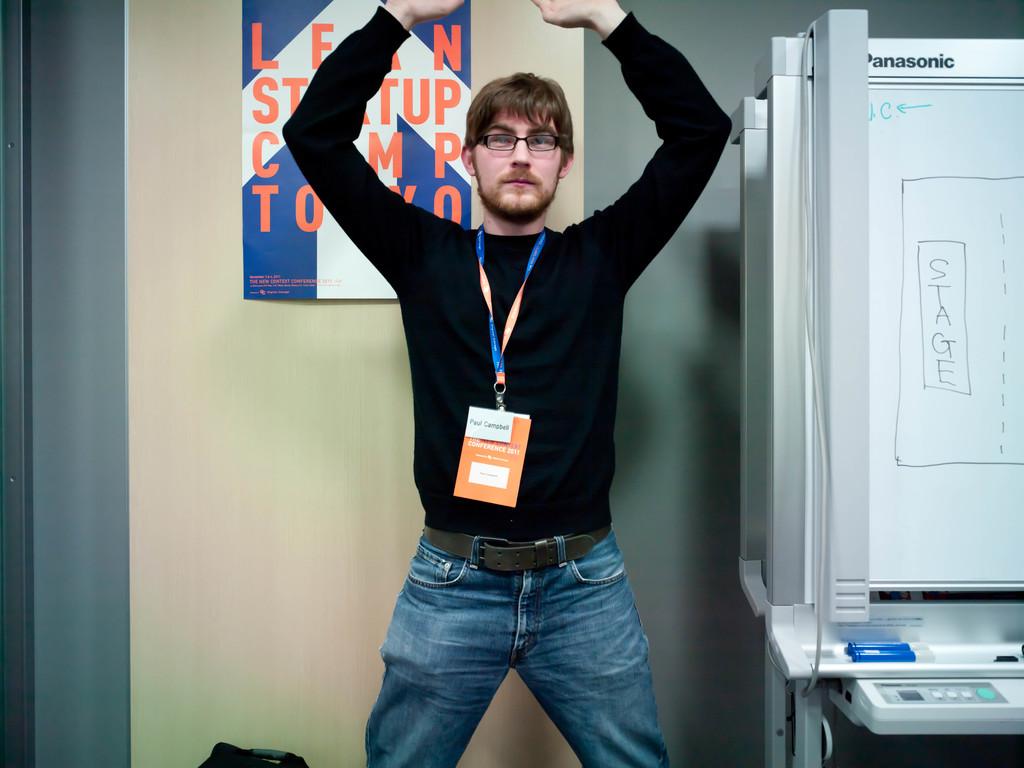What is the brand of the device on the right?
Keep it short and to the point. Panasonic. What is written on the whiteboard?
Your answer should be very brief. Stage. 